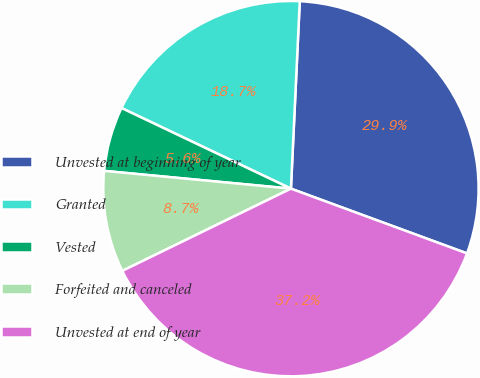Convert chart to OTSL. <chart><loc_0><loc_0><loc_500><loc_500><pie_chart><fcel>Unvested at beginning of year<fcel>Granted<fcel>Vested<fcel>Forfeited and canceled<fcel>Unvested at end of year<nl><fcel>29.86%<fcel>18.68%<fcel>5.56%<fcel>8.73%<fcel>37.17%<nl></chart> 